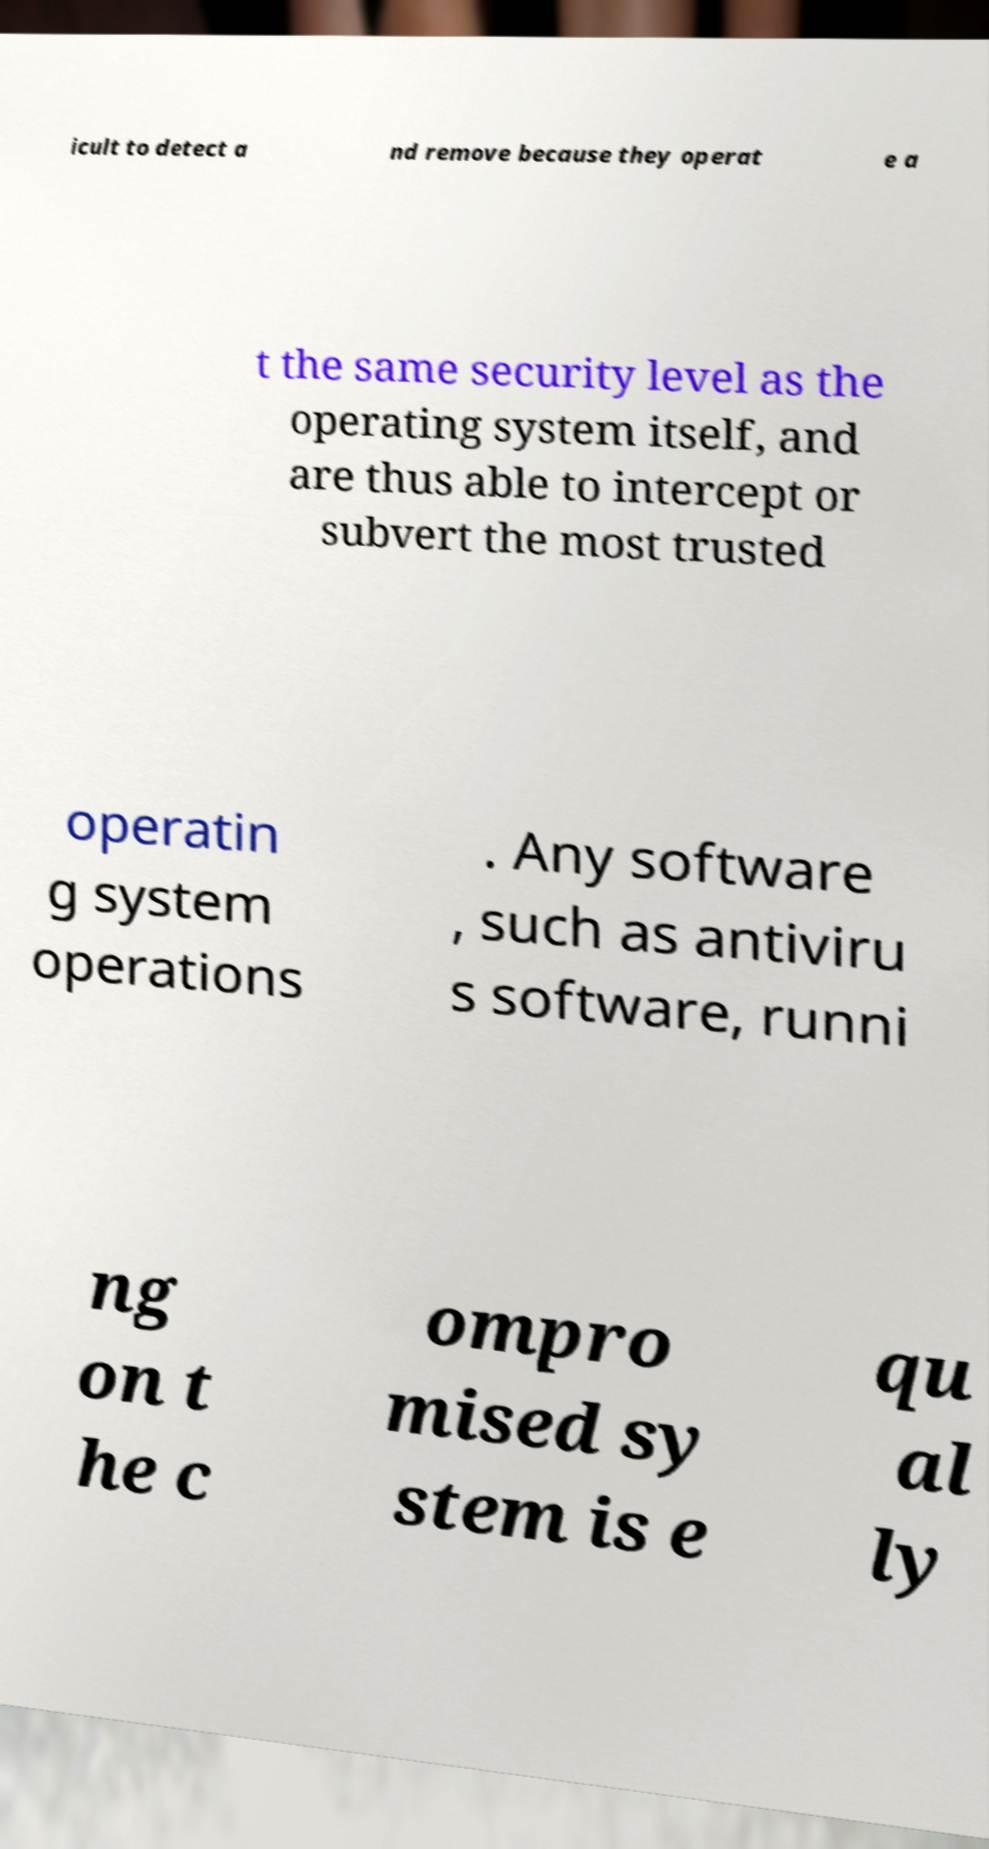For documentation purposes, I need the text within this image transcribed. Could you provide that? icult to detect a nd remove because they operat e a t the same security level as the operating system itself, and are thus able to intercept or subvert the most trusted operatin g system operations . Any software , such as antiviru s software, runni ng on t he c ompro mised sy stem is e qu al ly 